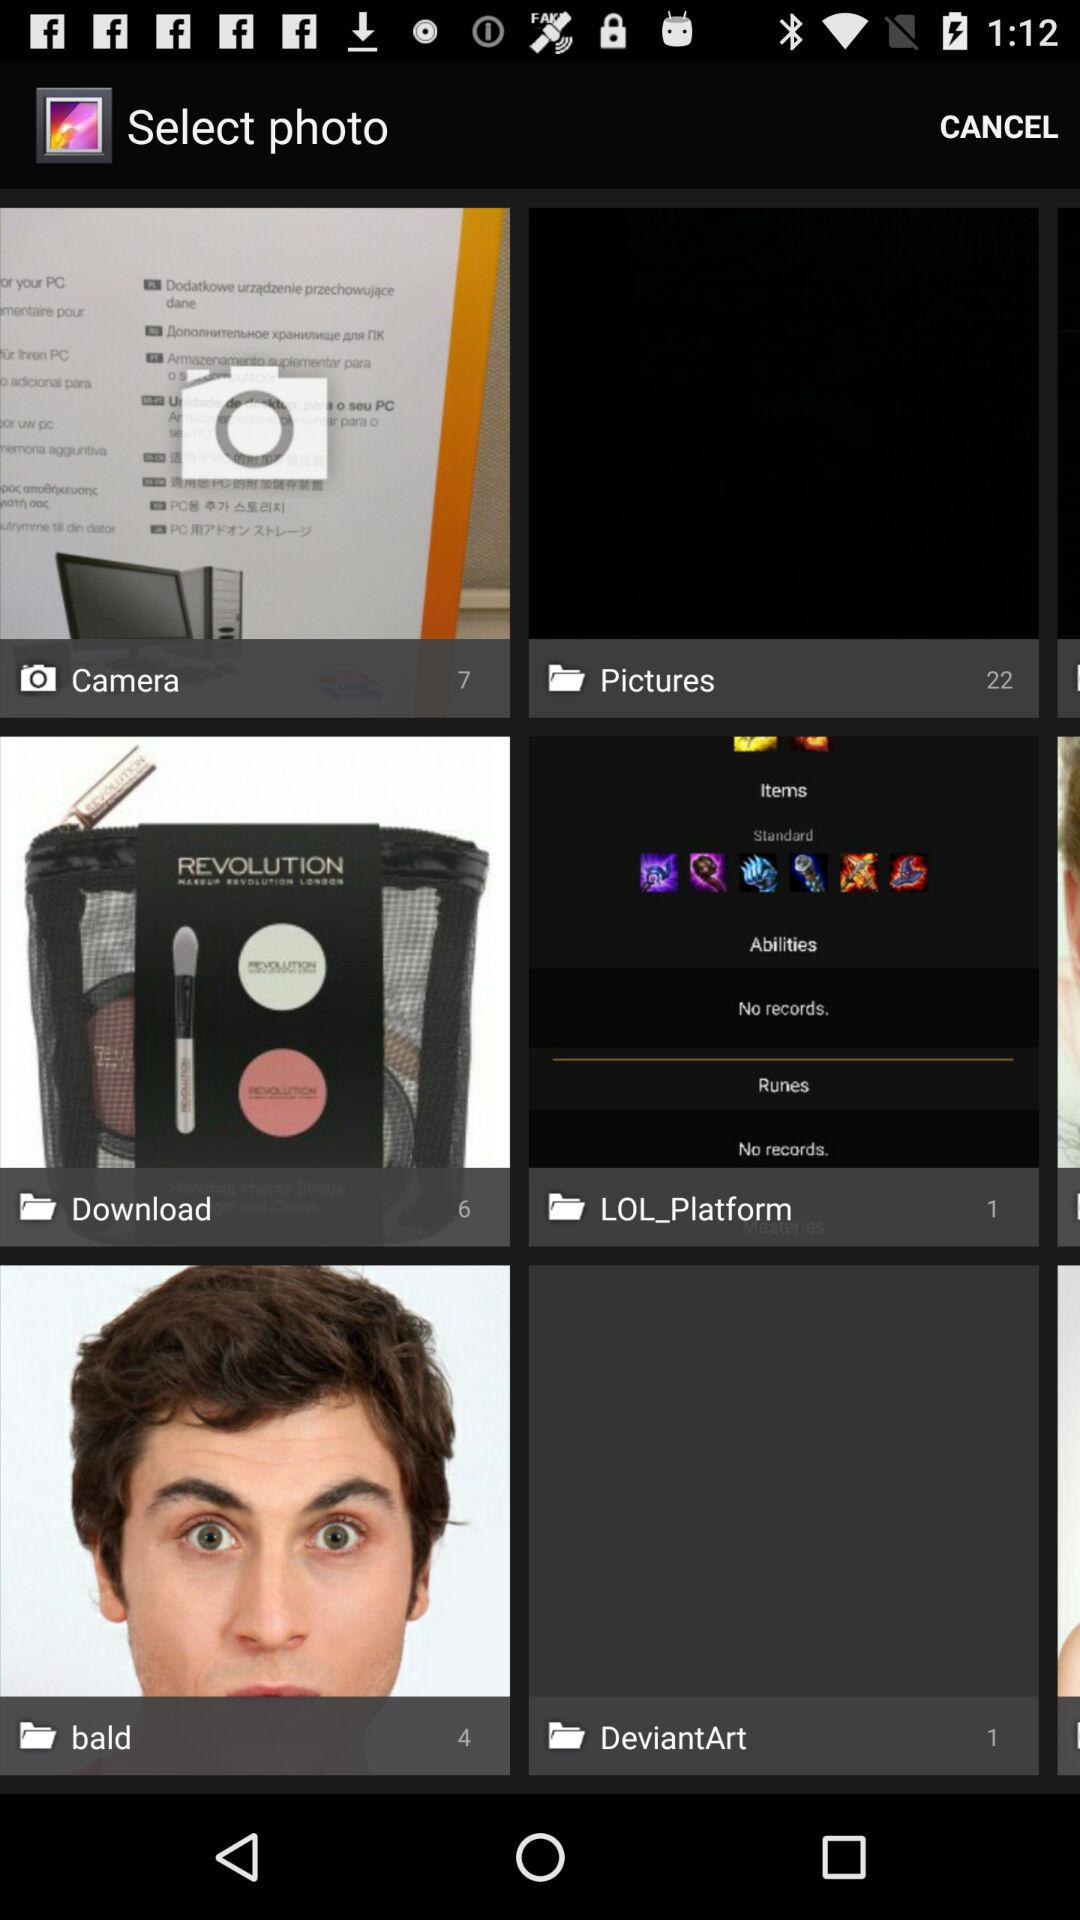How many pictures are in the camera folder? There are 7 pictures in the camera folder. 